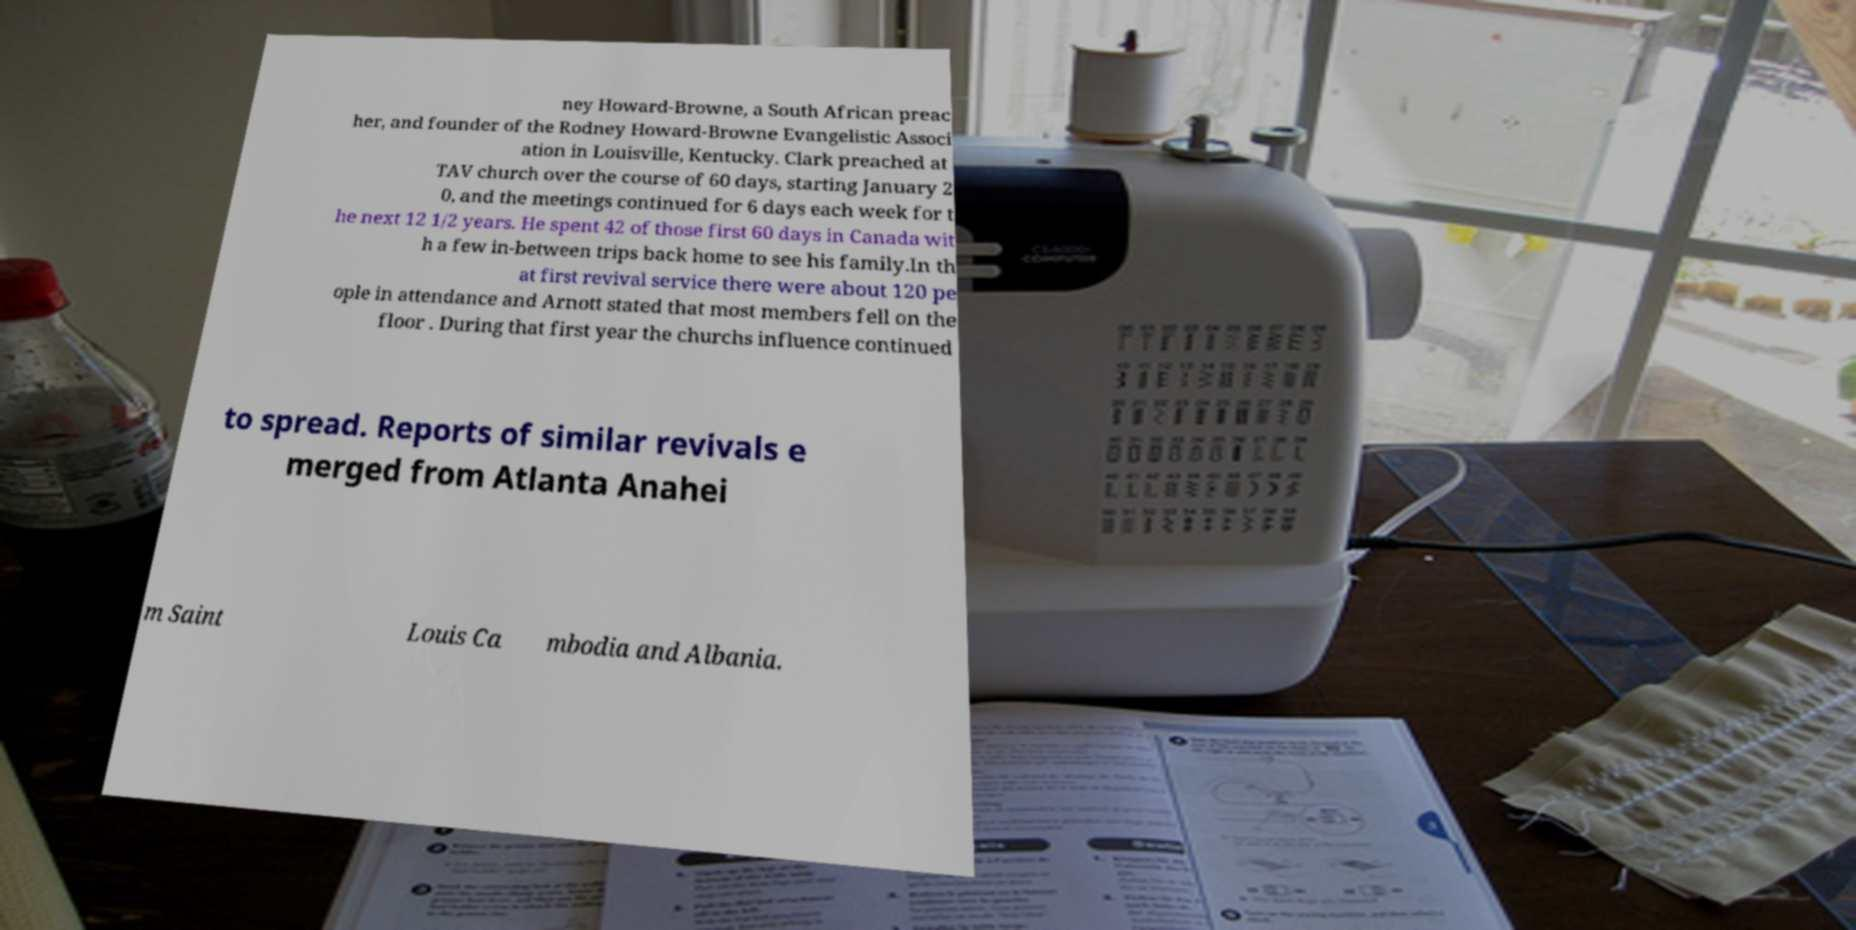Could you assist in decoding the text presented in this image and type it out clearly? ney Howard-Browne, a South African preac her, and founder of the Rodney Howard-Browne Evangelistic Associ ation in Louisville, Kentucky. Clark preached at TAV church over the course of 60 days, starting January 2 0, and the meetings continued for 6 days each week for t he next 12 1/2 years. He spent 42 of those first 60 days in Canada wit h a few in-between trips back home to see his family.In th at first revival service there were about 120 pe ople in attendance and Arnott stated that most members fell on the floor . During that first year the churchs influence continued to spread. Reports of similar revivals e merged from Atlanta Anahei m Saint Louis Ca mbodia and Albania. 